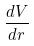Convert formula to latex. <formula><loc_0><loc_0><loc_500><loc_500>\frac { d V } { d r }</formula> 